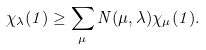<formula> <loc_0><loc_0><loc_500><loc_500>\chi _ { \lambda } ( 1 ) \geq \sum _ { \mu } N ( \mu , \lambda ) \chi _ { \mu } ( 1 ) .</formula> 